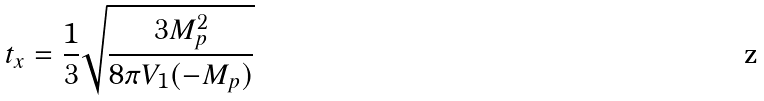<formula> <loc_0><loc_0><loc_500><loc_500>t _ { x } = \frac { 1 } { 3 } \sqrt { \frac { 3 M _ { p } ^ { 2 } } { 8 \pi V _ { 1 } ( - M _ { p } ) } }</formula> 